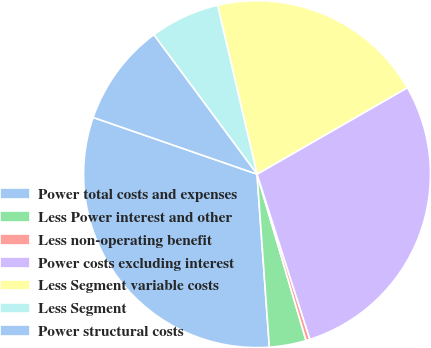Convert chart to OTSL. <chart><loc_0><loc_0><loc_500><loc_500><pie_chart><fcel>Power total costs and expenses<fcel>Less Power interest and other<fcel>Less non-operating benefit<fcel>Power costs excluding interest<fcel>Less Segment variable costs<fcel>Less Segment<fcel>Power structural costs<nl><fcel>31.44%<fcel>3.43%<fcel>0.37%<fcel>28.38%<fcel>20.34%<fcel>6.49%<fcel>9.55%<nl></chart> 